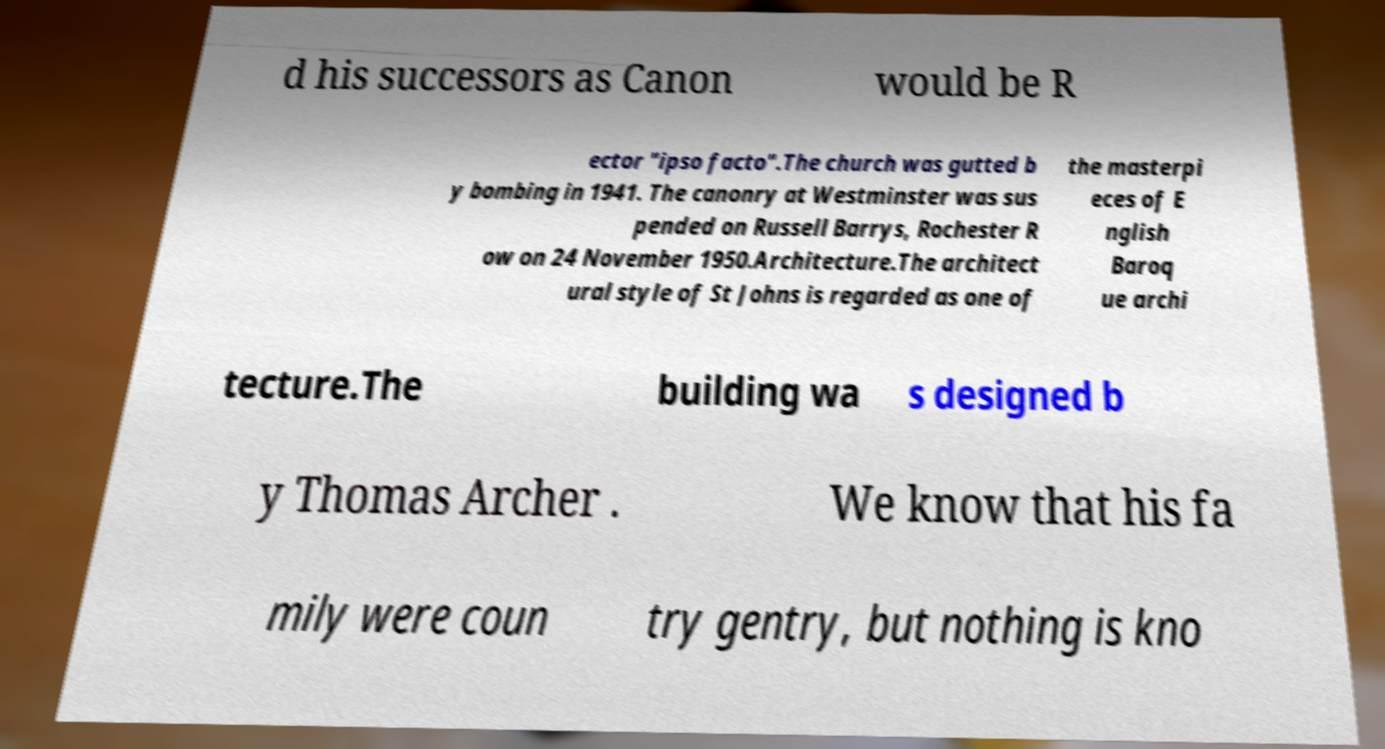Please identify and transcribe the text found in this image. d his successors as Canon would be R ector "ipso facto".The church was gutted b y bombing in 1941. The canonry at Westminster was sus pended on Russell Barrys, Rochester R ow on 24 November 1950.Architecture.The architect ural style of St Johns is regarded as one of the masterpi eces of E nglish Baroq ue archi tecture.The building wa s designed b y Thomas Archer . We know that his fa mily were coun try gentry, but nothing is kno 